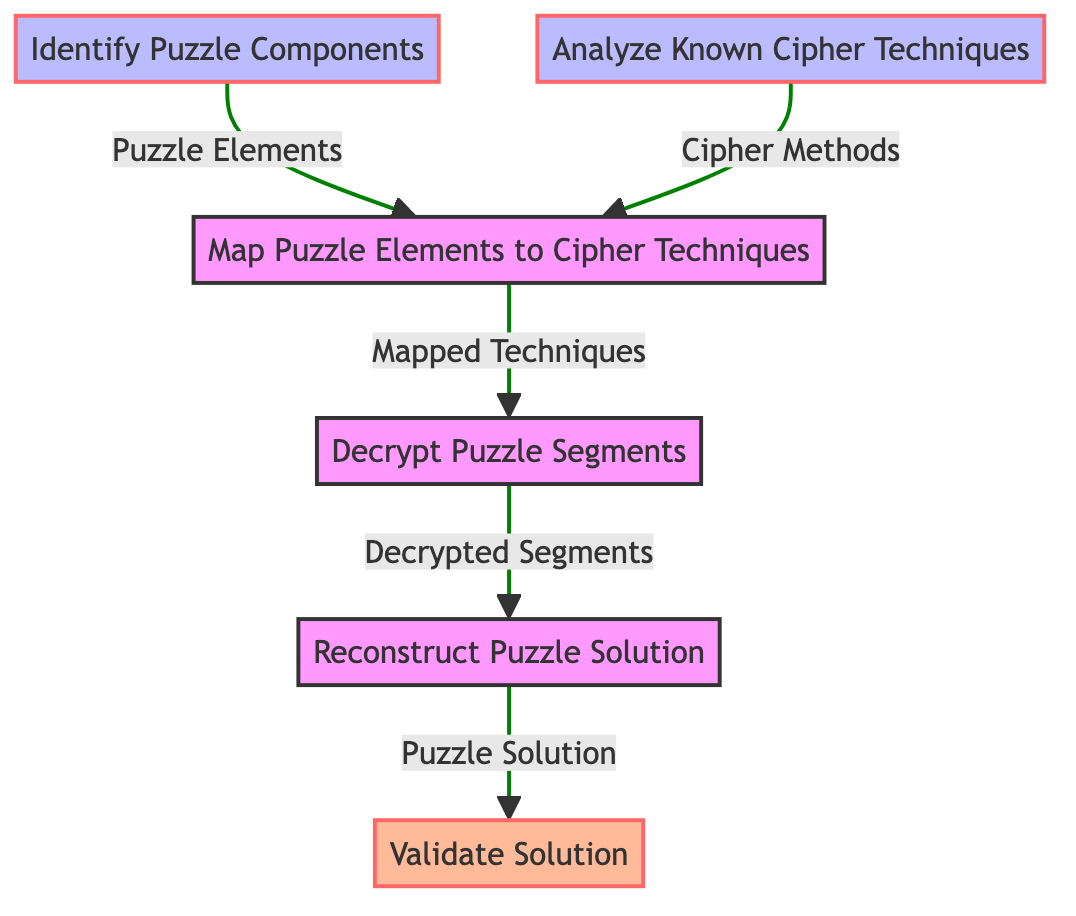What is the first step in the flow chart? The first step in the flow chart is "Identify Puzzle Components", which is the initial process in solving the complex puzzle.
Answer: Identify Puzzle Components How many total steps are outlined in the flow chart? The flow chart consists of six distinct steps: identifying components, analyzing cipher techniques, mapping techniques, decrypting segments, reconstructing the solution, and validating the solution.
Answer: Six What is the output of the third step? The third step, "Map Puzzle Elements to Cipher Techniques," produces the output labeled "Mapped Techniques."
Answer: Mapped Techniques Which step directly follows the "Decrypt Puzzle Segments"? The step that directly follows "Decrypt Puzzle Segments" is "Reconstruct Puzzle Solution," indicating that once segments are decrypted, the next action is to reconstruct the overall solution.
Answer: Reconstruct Puzzle Solution What are the inputs needed to perform the "Map Puzzle Elements to Cipher Techniques"? To perform "Map Puzzle Elements to Cipher Techniques," the inputs required are "Puzzle Elements" and "Cipher Methods," which will be utilized to determine suitable cryptographic techniques for each puzzle part.
Answer: Puzzle Elements, Cipher Methods How does "Validate Solution" relate to "Reconstruct Puzzle Solution"? "Validate Solution" is the final step that depends on the output from "Reconstruct Puzzle Solution," ensuring that the combined solution meets the original puzzle's requirements.
Answer: Validated Solution What is the output of the sixth step? The output of the sixth step, "Validate Solution," is "Validated Solution," indicating that the solution has been confirmed suitable against the original requirements.
Answer: Validated Solution What is the relationship between "Analyze Known Cipher Techniques" and "Map Puzzle Elements to Cipher Techniques"? "Analyze Known Cipher Techniques" provides necessary inputs, specifically "Cipher Methods," for the subsequent step "Map Puzzle Elements to Cipher Techniques," creating a dependency between the two.
Answer: Dependency Which nodes have no inputs in the flow chart? The first two nodes, "Identify Puzzle Components" and "Analyze Known Cipher Techniques," have no inputs, functioning independently as the initial steps in the process.
Answer: Identify Puzzle Components, Analyze Known Cipher Techniques 